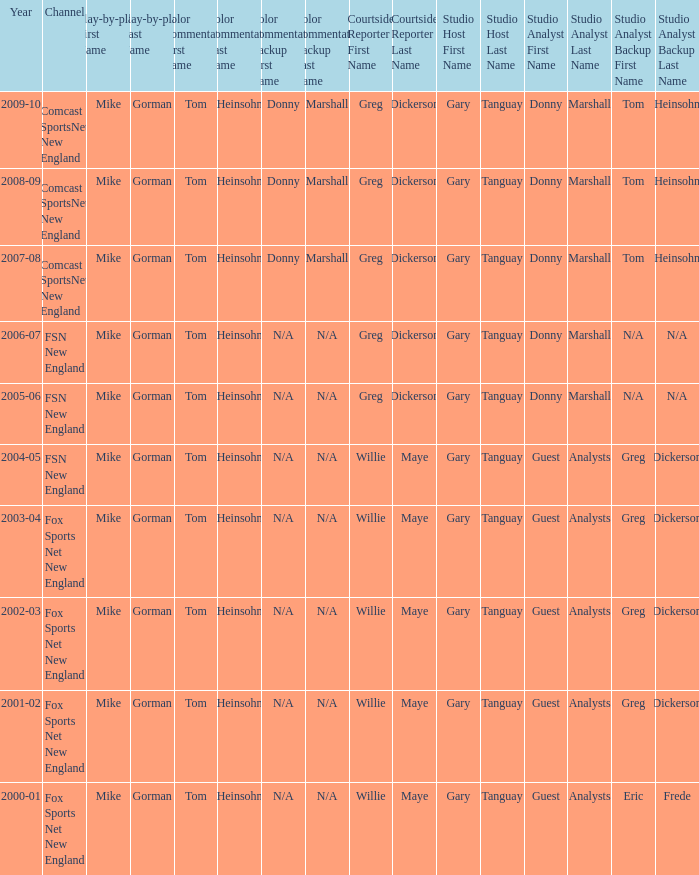Which studio anchor has a year of 2003-04? Gary Tanguay & Greg Dickerson. 